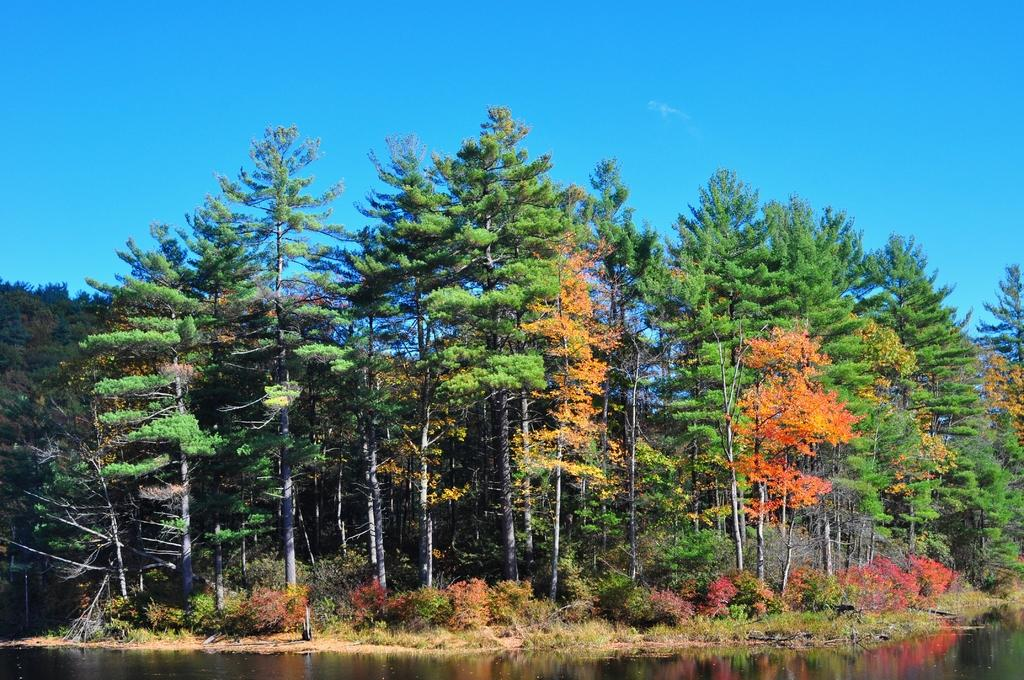What type of vegetation can be seen in the image? There are many trees and plants in the image. What part of the natural environment is visible in the image? The sky and a lake with a water surface are visible in the image. What is the relationship between the trees and the lake in the image? The reflections of the trees are visible on the water surface of the lake. What color crayon is being used to draw the lake in the image? There is no crayon present in the image; it is a photograph or illustration of a natural scene. 